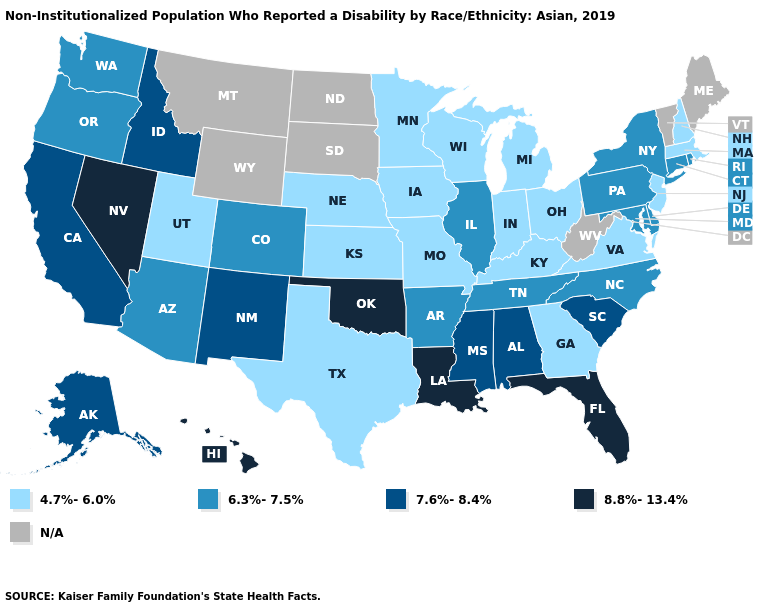Which states hav the highest value in the MidWest?
Write a very short answer. Illinois. Among the states that border Vermont , does New York have the highest value?
Quick response, please. Yes. Which states hav the highest value in the South?
Keep it brief. Florida, Louisiana, Oklahoma. Name the states that have a value in the range 6.3%-7.5%?
Answer briefly. Arizona, Arkansas, Colorado, Connecticut, Delaware, Illinois, Maryland, New York, North Carolina, Oregon, Pennsylvania, Rhode Island, Tennessee, Washington. What is the value of South Dakota?
Concise answer only. N/A. Does Michigan have the lowest value in the USA?
Keep it brief. Yes. What is the value of Colorado?
Answer briefly. 6.3%-7.5%. What is the lowest value in the USA?
Quick response, please. 4.7%-6.0%. Among the states that border Vermont , does New York have the highest value?
Be succinct. Yes. What is the lowest value in the USA?
Write a very short answer. 4.7%-6.0%. What is the value of Kansas?
Be succinct. 4.7%-6.0%. Does Delaware have the highest value in the USA?
Short answer required. No. What is the lowest value in states that border Montana?
Write a very short answer. 7.6%-8.4%. 